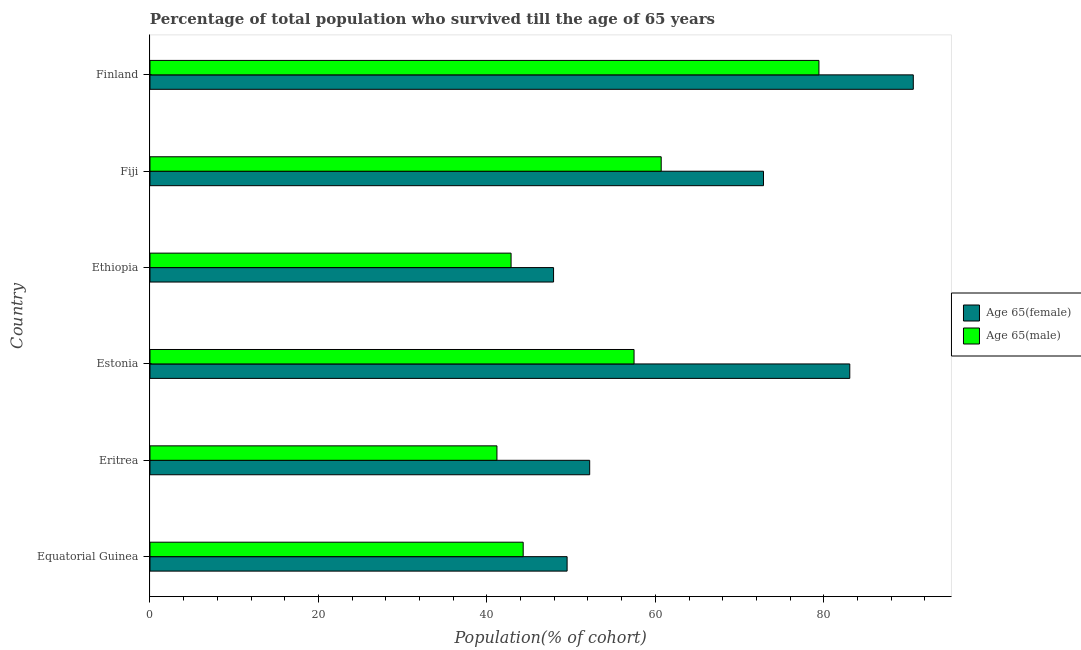What is the label of the 2nd group of bars from the top?
Your answer should be very brief. Fiji. What is the percentage of male population who survived till age of 65 in Ethiopia?
Your response must be concise. 42.87. Across all countries, what is the maximum percentage of female population who survived till age of 65?
Offer a very short reply. 90.63. Across all countries, what is the minimum percentage of female population who survived till age of 65?
Your answer should be very brief. 47.92. In which country was the percentage of female population who survived till age of 65 maximum?
Keep it short and to the point. Finland. In which country was the percentage of male population who survived till age of 65 minimum?
Give a very brief answer. Eritrea. What is the total percentage of female population who survived till age of 65 in the graph?
Provide a succinct answer. 396.21. What is the difference between the percentage of female population who survived till age of 65 in Ethiopia and that in Fiji?
Offer a very short reply. -24.92. What is the difference between the percentage of male population who survived till age of 65 in Fiji and the percentage of female population who survived till age of 65 in Finland?
Offer a terse response. -29.93. What is the average percentage of female population who survived till age of 65 per country?
Your answer should be compact. 66.03. What is the difference between the percentage of female population who survived till age of 65 and percentage of male population who survived till age of 65 in Fiji?
Your answer should be very brief. 12.14. In how many countries, is the percentage of female population who survived till age of 65 greater than 32 %?
Make the answer very short. 6. What is the ratio of the percentage of female population who survived till age of 65 in Eritrea to that in Estonia?
Your answer should be very brief. 0.63. What is the difference between the highest and the second highest percentage of male population who survived till age of 65?
Your answer should be compact. 18.73. What is the difference between the highest and the lowest percentage of male population who survived till age of 65?
Provide a succinct answer. 38.23. What does the 1st bar from the top in Eritrea represents?
Provide a short and direct response. Age 65(male). What does the 2nd bar from the bottom in Finland represents?
Ensure brevity in your answer.  Age 65(male). Are all the bars in the graph horizontal?
Give a very brief answer. Yes. Are the values on the major ticks of X-axis written in scientific E-notation?
Offer a terse response. No. Does the graph contain any zero values?
Keep it short and to the point. No. How many legend labels are there?
Make the answer very short. 2. How are the legend labels stacked?
Offer a very short reply. Vertical. What is the title of the graph?
Ensure brevity in your answer.  Percentage of total population who survived till the age of 65 years. What is the label or title of the X-axis?
Offer a very short reply. Population(% of cohort). What is the Population(% of cohort) of Age 65(female) in Equatorial Guinea?
Ensure brevity in your answer.  49.53. What is the Population(% of cohort) of Age 65(male) in Equatorial Guinea?
Give a very brief answer. 44.31. What is the Population(% of cohort) in Age 65(female) in Eritrea?
Offer a very short reply. 52.21. What is the Population(% of cohort) of Age 65(male) in Eritrea?
Ensure brevity in your answer.  41.19. What is the Population(% of cohort) of Age 65(female) in Estonia?
Ensure brevity in your answer.  83.09. What is the Population(% of cohort) in Age 65(male) in Estonia?
Offer a terse response. 57.47. What is the Population(% of cohort) of Age 65(female) in Ethiopia?
Ensure brevity in your answer.  47.92. What is the Population(% of cohort) in Age 65(male) in Ethiopia?
Give a very brief answer. 42.87. What is the Population(% of cohort) of Age 65(female) in Fiji?
Offer a very short reply. 72.84. What is the Population(% of cohort) of Age 65(male) in Fiji?
Make the answer very short. 60.7. What is the Population(% of cohort) of Age 65(female) in Finland?
Keep it short and to the point. 90.63. What is the Population(% of cohort) of Age 65(male) in Finland?
Your answer should be very brief. 79.43. Across all countries, what is the maximum Population(% of cohort) in Age 65(female)?
Give a very brief answer. 90.63. Across all countries, what is the maximum Population(% of cohort) in Age 65(male)?
Ensure brevity in your answer.  79.43. Across all countries, what is the minimum Population(% of cohort) in Age 65(female)?
Ensure brevity in your answer.  47.92. Across all countries, what is the minimum Population(% of cohort) of Age 65(male)?
Make the answer very short. 41.19. What is the total Population(% of cohort) in Age 65(female) in the graph?
Your answer should be very brief. 396.21. What is the total Population(% of cohort) of Age 65(male) in the graph?
Provide a short and direct response. 325.98. What is the difference between the Population(% of cohort) in Age 65(female) in Equatorial Guinea and that in Eritrea?
Your response must be concise. -2.68. What is the difference between the Population(% of cohort) of Age 65(male) in Equatorial Guinea and that in Eritrea?
Offer a very short reply. 3.12. What is the difference between the Population(% of cohort) of Age 65(female) in Equatorial Guinea and that in Estonia?
Provide a short and direct response. -33.56. What is the difference between the Population(% of cohort) in Age 65(male) in Equatorial Guinea and that in Estonia?
Keep it short and to the point. -13.16. What is the difference between the Population(% of cohort) in Age 65(female) in Equatorial Guinea and that in Ethiopia?
Offer a terse response. 1.61. What is the difference between the Population(% of cohort) in Age 65(male) in Equatorial Guinea and that in Ethiopia?
Your answer should be compact. 1.44. What is the difference between the Population(% of cohort) in Age 65(female) in Equatorial Guinea and that in Fiji?
Offer a terse response. -23.32. What is the difference between the Population(% of cohort) of Age 65(male) in Equatorial Guinea and that in Fiji?
Your response must be concise. -16.39. What is the difference between the Population(% of cohort) of Age 65(female) in Equatorial Guinea and that in Finland?
Give a very brief answer. -41.1. What is the difference between the Population(% of cohort) of Age 65(male) in Equatorial Guinea and that in Finland?
Ensure brevity in your answer.  -35.12. What is the difference between the Population(% of cohort) in Age 65(female) in Eritrea and that in Estonia?
Your answer should be compact. -30.88. What is the difference between the Population(% of cohort) of Age 65(male) in Eritrea and that in Estonia?
Provide a short and direct response. -16.28. What is the difference between the Population(% of cohort) in Age 65(female) in Eritrea and that in Ethiopia?
Offer a terse response. 4.29. What is the difference between the Population(% of cohort) of Age 65(male) in Eritrea and that in Ethiopia?
Provide a short and direct response. -1.68. What is the difference between the Population(% of cohort) in Age 65(female) in Eritrea and that in Fiji?
Make the answer very short. -20.63. What is the difference between the Population(% of cohort) in Age 65(male) in Eritrea and that in Fiji?
Offer a very short reply. -19.5. What is the difference between the Population(% of cohort) of Age 65(female) in Eritrea and that in Finland?
Ensure brevity in your answer.  -38.42. What is the difference between the Population(% of cohort) of Age 65(male) in Eritrea and that in Finland?
Make the answer very short. -38.23. What is the difference between the Population(% of cohort) in Age 65(female) in Estonia and that in Ethiopia?
Keep it short and to the point. 35.17. What is the difference between the Population(% of cohort) in Age 65(male) in Estonia and that in Ethiopia?
Make the answer very short. 14.6. What is the difference between the Population(% of cohort) in Age 65(female) in Estonia and that in Fiji?
Your response must be concise. 10.25. What is the difference between the Population(% of cohort) in Age 65(male) in Estonia and that in Fiji?
Provide a succinct answer. -3.22. What is the difference between the Population(% of cohort) of Age 65(female) in Estonia and that in Finland?
Your answer should be very brief. -7.54. What is the difference between the Population(% of cohort) of Age 65(male) in Estonia and that in Finland?
Keep it short and to the point. -21.95. What is the difference between the Population(% of cohort) of Age 65(female) in Ethiopia and that in Fiji?
Your answer should be very brief. -24.92. What is the difference between the Population(% of cohort) in Age 65(male) in Ethiopia and that in Fiji?
Your answer should be very brief. -17.83. What is the difference between the Population(% of cohort) in Age 65(female) in Ethiopia and that in Finland?
Your answer should be compact. -42.71. What is the difference between the Population(% of cohort) of Age 65(male) in Ethiopia and that in Finland?
Provide a succinct answer. -36.55. What is the difference between the Population(% of cohort) in Age 65(female) in Fiji and that in Finland?
Your response must be concise. -17.79. What is the difference between the Population(% of cohort) in Age 65(male) in Fiji and that in Finland?
Provide a short and direct response. -18.73. What is the difference between the Population(% of cohort) in Age 65(female) in Equatorial Guinea and the Population(% of cohort) in Age 65(male) in Eritrea?
Provide a succinct answer. 8.33. What is the difference between the Population(% of cohort) in Age 65(female) in Equatorial Guinea and the Population(% of cohort) in Age 65(male) in Estonia?
Provide a short and direct response. -7.95. What is the difference between the Population(% of cohort) in Age 65(female) in Equatorial Guinea and the Population(% of cohort) in Age 65(male) in Ethiopia?
Give a very brief answer. 6.65. What is the difference between the Population(% of cohort) in Age 65(female) in Equatorial Guinea and the Population(% of cohort) in Age 65(male) in Fiji?
Offer a terse response. -11.17. What is the difference between the Population(% of cohort) in Age 65(female) in Equatorial Guinea and the Population(% of cohort) in Age 65(male) in Finland?
Provide a succinct answer. -29.9. What is the difference between the Population(% of cohort) in Age 65(female) in Eritrea and the Population(% of cohort) in Age 65(male) in Estonia?
Offer a very short reply. -5.27. What is the difference between the Population(% of cohort) of Age 65(female) in Eritrea and the Population(% of cohort) of Age 65(male) in Ethiopia?
Your answer should be very brief. 9.34. What is the difference between the Population(% of cohort) in Age 65(female) in Eritrea and the Population(% of cohort) in Age 65(male) in Fiji?
Ensure brevity in your answer.  -8.49. What is the difference between the Population(% of cohort) of Age 65(female) in Eritrea and the Population(% of cohort) of Age 65(male) in Finland?
Your response must be concise. -27.22. What is the difference between the Population(% of cohort) of Age 65(female) in Estonia and the Population(% of cohort) of Age 65(male) in Ethiopia?
Ensure brevity in your answer.  40.22. What is the difference between the Population(% of cohort) in Age 65(female) in Estonia and the Population(% of cohort) in Age 65(male) in Fiji?
Your answer should be very brief. 22.39. What is the difference between the Population(% of cohort) in Age 65(female) in Estonia and the Population(% of cohort) in Age 65(male) in Finland?
Give a very brief answer. 3.66. What is the difference between the Population(% of cohort) of Age 65(female) in Ethiopia and the Population(% of cohort) of Age 65(male) in Fiji?
Make the answer very short. -12.78. What is the difference between the Population(% of cohort) of Age 65(female) in Ethiopia and the Population(% of cohort) of Age 65(male) in Finland?
Offer a very short reply. -31.51. What is the difference between the Population(% of cohort) of Age 65(female) in Fiji and the Population(% of cohort) of Age 65(male) in Finland?
Your answer should be compact. -6.59. What is the average Population(% of cohort) in Age 65(female) per country?
Offer a very short reply. 66.04. What is the average Population(% of cohort) of Age 65(male) per country?
Make the answer very short. 54.33. What is the difference between the Population(% of cohort) of Age 65(female) and Population(% of cohort) of Age 65(male) in Equatorial Guinea?
Give a very brief answer. 5.21. What is the difference between the Population(% of cohort) in Age 65(female) and Population(% of cohort) in Age 65(male) in Eritrea?
Offer a terse response. 11.01. What is the difference between the Population(% of cohort) of Age 65(female) and Population(% of cohort) of Age 65(male) in Estonia?
Ensure brevity in your answer.  25.61. What is the difference between the Population(% of cohort) of Age 65(female) and Population(% of cohort) of Age 65(male) in Ethiopia?
Offer a very short reply. 5.05. What is the difference between the Population(% of cohort) of Age 65(female) and Population(% of cohort) of Age 65(male) in Fiji?
Give a very brief answer. 12.14. What is the difference between the Population(% of cohort) in Age 65(female) and Population(% of cohort) in Age 65(male) in Finland?
Keep it short and to the point. 11.2. What is the ratio of the Population(% of cohort) of Age 65(female) in Equatorial Guinea to that in Eritrea?
Provide a short and direct response. 0.95. What is the ratio of the Population(% of cohort) in Age 65(male) in Equatorial Guinea to that in Eritrea?
Your response must be concise. 1.08. What is the ratio of the Population(% of cohort) of Age 65(female) in Equatorial Guinea to that in Estonia?
Provide a succinct answer. 0.6. What is the ratio of the Population(% of cohort) in Age 65(male) in Equatorial Guinea to that in Estonia?
Offer a very short reply. 0.77. What is the ratio of the Population(% of cohort) in Age 65(female) in Equatorial Guinea to that in Ethiopia?
Offer a very short reply. 1.03. What is the ratio of the Population(% of cohort) in Age 65(male) in Equatorial Guinea to that in Ethiopia?
Make the answer very short. 1.03. What is the ratio of the Population(% of cohort) of Age 65(female) in Equatorial Guinea to that in Fiji?
Offer a terse response. 0.68. What is the ratio of the Population(% of cohort) in Age 65(male) in Equatorial Guinea to that in Fiji?
Offer a terse response. 0.73. What is the ratio of the Population(% of cohort) of Age 65(female) in Equatorial Guinea to that in Finland?
Your answer should be compact. 0.55. What is the ratio of the Population(% of cohort) in Age 65(male) in Equatorial Guinea to that in Finland?
Keep it short and to the point. 0.56. What is the ratio of the Population(% of cohort) in Age 65(female) in Eritrea to that in Estonia?
Provide a succinct answer. 0.63. What is the ratio of the Population(% of cohort) of Age 65(male) in Eritrea to that in Estonia?
Offer a very short reply. 0.72. What is the ratio of the Population(% of cohort) of Age 65(female) in Eritrea to that in Ethiopia?
Offer a terse response. 1.09. What is the ratio of the Population(% of cohort) of Age 65(male) in Eritrea to that in Ethiopia?
Make the answer very short. 0.96. What is the ratio of the Population(% of cohort) in Age 65(female) in Eritrea to that in Fiji?
Your answer should be compact. 0.72. What is the ratio of the Population(% of cohort) in Age 65(male) in Eritrea to that in Fiji?
Offer a very short reply. 0.68. What is the ratio of the Population(% of cohort) of Age 65(female) in Eritrea to that in Finland?
Your response must be concise. 0.58. What is the ratio of the Population(% of cohort) in Age 65(male) in Eritrea to that in Finland?
Ensure brevity in your answer.  0.52. What is the ratio of the Population(% of cohort) of Age 65(female) in Estonia to that in Ethiopia?
Your answer should be very brief. 1.73. What is the ratio of the Population(% of cohort) of Age 65(male) in Estonia to that in Ethiopia?
Your response must be concise. 1.34. What is the ratio of the Population(% of cohort) of Age 65(female) in Estonia to that in Fiji?
Ensure brevity in your answer.  1.14. What is the ratio of the Population(% of cohort) in Age 65(male) in Estonia to that in Fiji?
Your response must be concise. 0.95. What is the ratio of the Population(% of cohort) of Age 65(female) in Estonia to that in Finland?
Provide a short and direct response. 0.92. What is the ratio of the Population(% of cohort) of Age 65(male) in Estonia to that in Finland?
Your response must be concise. 0.72. What is the ratio of the Population(% of cohort) of Age 65(female) in Ethiopia to that in Fiji?
Your answer should be very brief. 0.66. What is the ratio of the Population(% of cohort) of Age 65(male) in Ethiopia to that in Fiji?
Provide a short and direct response. 0.71. What is the ratio of the Population(% of cohort) in Age 65(female) in Ethiopia to that in Finland?
Offer a very short reply. 0.53. What is the ratio of the Population(% of cohort) of Age 65(male) in Ethiopia to that in Finland?
Your response must be concise. 0.54. What is the ratio of the Population(% of cohort) in Age 65(female) in Fiji to that in Finland?
Provide a succinct answer. 0.8. What is the ratio of the Population(% of cohort) of Age 65(male) in Fiji to that in Finland?
Offer a terse response. 0.76. What is the difference between the highest and the second highest Population(% of cohort) of Age 65(female)?
Your answer should be very brief. 7.54. What is the difference between the highest and the second highest Population(% of cohort) of Age 65(male)?
Offer a terse response. 18.73. What is the difference between the highest and the lowest Population(% of cohort) in Age 65(female)?
Ensure brevity in your answer.  42.71. What is the difference between the highest and the lowest Population(% of cohort) of Age 65(male)?
Offer a very short reply. 38.23. 